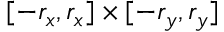Convert formula to latex. <formula><loc_0><loc_0><loc_500><loc_500>[ - r _ { x } , r _ { x } ] \times [ - r _ { y } , r _ { y } ]</formula> 